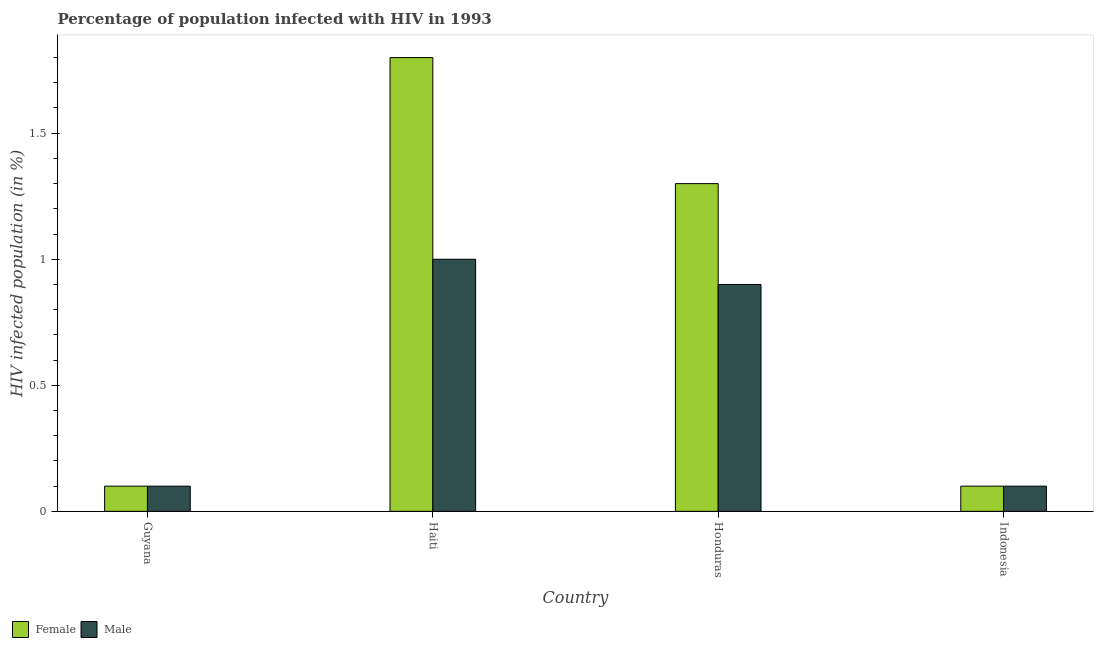How many different coloured bars are there?
Your answer should be compact. 2. How many groups of bars are there?
Your answer should be very brief. 4. What is the label of the 3rd group of bars from the left?
Your answer should be very brief. Honduras. In how many cases, is the number of bars for a given country not equal to the number of legend labels?
Offer a terse response. 0. Across all countries, what is the maximum percentage of males who are infected with hiv?
Provide a succinct answer. 1. Across all countries, what is the minimum percentage of females who are infected with hiv?
Offer a very short reply. 0.1. In which country was the percentage of males who are infected with hiv maximum?
Keep it short and to the point. Haiti. In which country was the percentage of males who are infected with hiv minimum?
Keep it short and to the point. Guyana. What is the total percentage of males who are infected with hiv in the graph?
Your answer should be very brief. 2.1. What is the difference between the percentage of males who are infected with hiv in Haiti and that in Honduras?
Offer a terse response. 0.1. What is the average percentage of females who are infected with hiv per country?
Offer a very short reply. 0.83. What is the ratio of the percentage of males who are infected with hiv in Guyana to that in Honduras?
Your response must be concise. 0.11. Is the percentage of males who are infected with hiv in Honduras less than that in Indonesia?
Give a very brief answer. No. What is the difference between the highest and the second highest percentage of males who are infected with hiv?
Give a very brief answer. 0.1. What is the difference between the highest and the lowest percentage of females who are infected with hiv?
Provide a short and direct response. 1.7. In how many countries, is the percentage of females who are infected with hiv greater than the average percentage of females who are infected with hiv taken over all countries?
Give a very brief answer. 2. Is the sum of the percentage of females who are infected with hiv in Haiti and Honduras greater than the maximum percentage of males who are infected with hiv across all countries?
Ensure brevity in your answer.  Yes. What does the 1st bar from the left in Haiti represents?
Make the answer very short. Female. Are all the bars in the graph horizontal?
Your answer should be very brief. No. Are the values on the major ticks of Y-axis written in scientific E-notation?
Offer a terse response. No. Does the graph contain grids?
Provide a short and direct response. No. Where does the legend appear in the graph?
Offer a terse response. Bottom left. How many legend labels are there?
Your answer should be very brief. 2. What is the title of the graph?
Offer a very short reply. Percentage of population infected with HIV in 1993. What is the label or title of the Y-axis?
Your answer should be very brief. HIV infected population (in %). What is the HIV infected population (in %) in Male in Guyana?
Offer a terse response. 0.1. What is the HIV infected population (in %) of Male in Haiti?
Offer a terse response. 1. What is the HIV infected population (in %) of Female in Indonesia?
Provide a succinct answer. 0.1. Across all countries, what is the maximum HIV infected population (in %) of Female?
Provide a succinct answer. 1.8. Across all countries, what is the maximum HIV infected population (in %) in Male?
Offer a very short reply. 1. Across all countries, what is the minimum HIV infected population (in %) of Male?
Offer a terse response. 0.1. What is the total HIV infected population (in %) of Female in the graph?
Your answer should be compact. 3.3. What is the total HIV infected population (in %) in Male in the graph?
Provide a succinct answer. 2.1. What is the difference between the HIV infected population (in %) in Male in Guyana and that in Haiti?
Keep it short and to the point. -0.9. What is the difference between the HIV infected population (in %) in Female in Guyana and that in Honduras?
Ensure brevity in your answer.  -1.2. What is the difference between the HIV infected population (in %) in Male in Guyana and that in Honduras?
Ensure brevity in your answer.  -0.8. What is the difference between the HIV infected population (in %) in Female in Guyana and that in Indonesia?
Offer a very short reply. 0. What is the difference between the HIV infected population (in %) of Female in Haiti and that in Honduras?
Provide a short and direct response. 0.5. What is the difference between the HIV infected population (in %) in Female in Haiti and that in Indonesia?
Make the answer very short. 1.7. What is the difference between the HIV infected population (in %) in Male in Haiti and that in Indonesia?
Your response must be concise. 0.9. What is the difference between the HIV infected population (in %) of Male in Honduras and that in Indonesia?
Your response must be concise. 0.8. What is the difference between the HIV infected population (in %) in Female in Haiti and the HIV infected population (in %) in Male in Honduras?
Offer a very short reply. 0.9. What is the difference between the HIV infected population (in %) of Female in Haiti and the HIV infected population (in %) of Male in Indonesia?
Make the answer very short. 1.7. What is the difference between the HIV infected population (in %) in Female in Honduras and the HIV infected population (in %) in Male in Indonesia?
Provide a short and direct response. 1.2. What is the average HIV infected population (in %) in Female per country?
Your answer should be very brief. 0.82. What is the average HIV infected population (in %) of Male per country?
Your response must be concise. 0.53. What is the difference between the HIV infected population (in %) of Female and HIV infected population (in %) of Male in Guyana?
Your answer should be compact. 0. What is the difference between the HIV infected population (in %) in Female and HIV infected population (in %) in Male in Honduras?
Offer a very short reply. 0.4. What is the difference between the HIV infected population (in %) of Female and HIV infected population (in %) of Male in Indonesia?
Provide a succinct answer. 0. What is the ratio of the HIV infected population (in %) in Female in Guyana to that in Haiti?
Your answer should be compact. 0.06. What is the ratio of the HIV infected population (in %) of Female in Guyana to that in Honduras?
Your response must be concise. 0.08. What is the ratio of the HIV infected population (in %) in Male in Guyana to that in Honduras?
Provide a short and direct response. 0.11. What is the ratio of the HIV infected population (in %) of Male in Guyana to that in Indonesia?
Make the answer very short. 1. What is the ratio of the HIV infected population (in %) of Female in Haiti to that in Honduras?
Your response must be concise. 1.38. What is the ratio of the HIV infected population (in %) in Male in Haiti to that in Honduras?
Give a very brief answer. 1.11. What is the ratio of the HIV infected population (in %) in Male in Haiti to that in Indonesia?
Keep it short and to the point. 10. What is the ratio of the HIV infected population (in %) of Female in Honduras to that in Indonesia?
Keep it short and to the point. 13. What is the ratio of the HIV infected population (in %) of Male in Honduras to that in Indonesia?
Keep it short and to the point. 9. What is the difference between the highest and the lowest HIV infected population (in %) of Male?
Your answer should be compact. 0.9. 